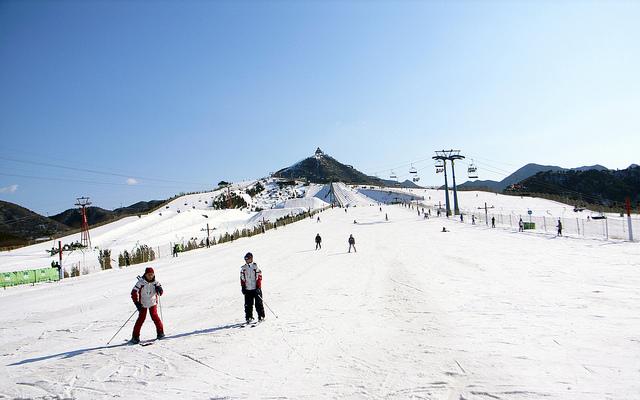Is this a steep hill?
Answer briefly. No. What are the people doing?
Concise answer only. Skiing. How many people are present?
Short answer required. 10. Is it sunny?
Write a very short answer. Yes. 